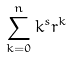Convert formula to latex. <formula><loc_0><loc_0><loc_500><loc_500>\sum _ { k = 0 } ^ { n } k ^ { s } r ^ { k }</formula> 